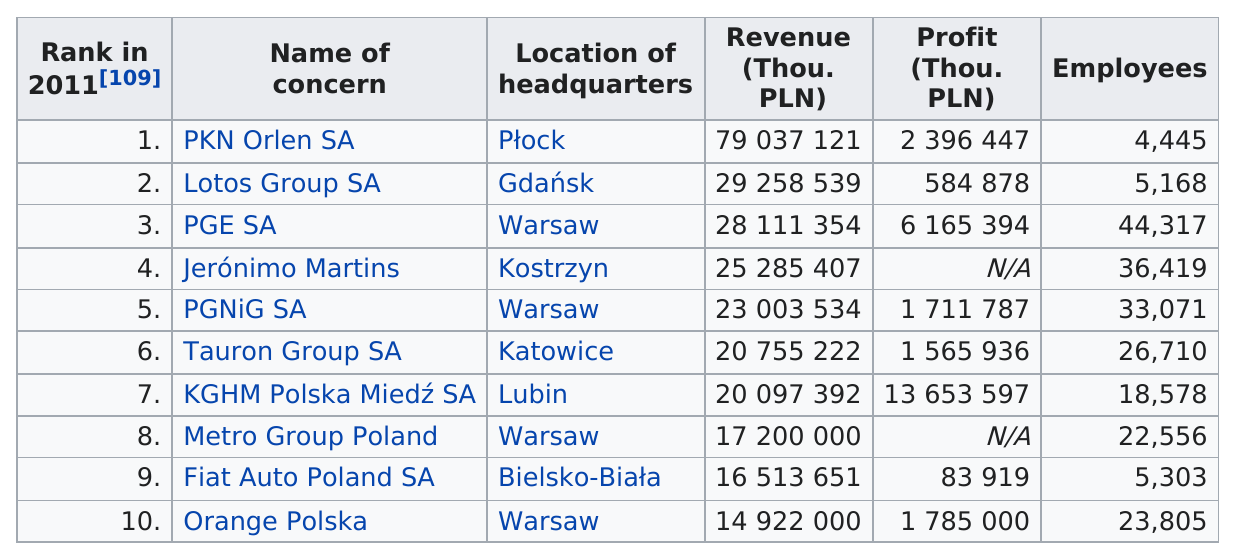Identify some key points in this picture. There is a difference of approximately 39,872 employees between rank 1 and rank 3. As many as six companies had accumulated over $1,000,000 in profits. Orange Polska, a company, placed last in its respective field. According to the information provided, PKN Orlen SA had the most revenue. It is not the case that every company has a profit number listed," the speaker declared. 